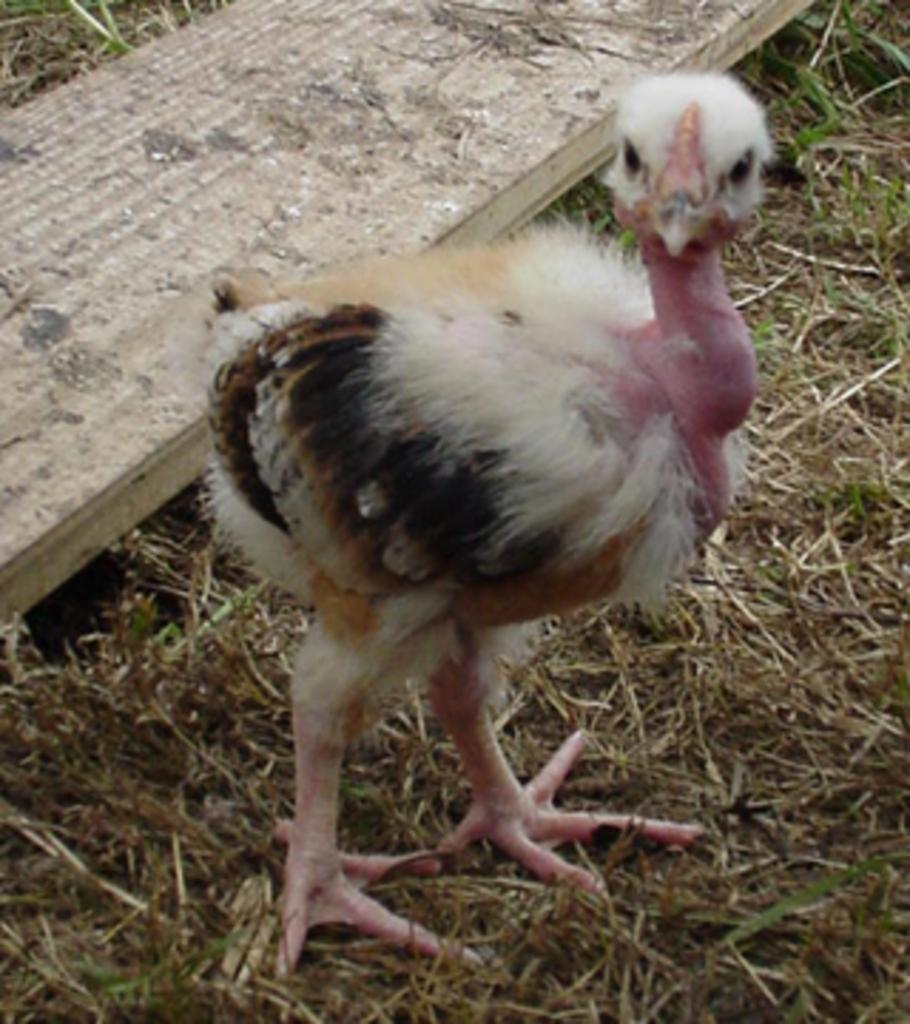What type of animal can be seen in the image? There is a bird in the image. What material is the sheet in the image made of? There is a wooden sheet in the image. What type of vegetation is visible in the image? There is grass in the image. What type of pencil can be seen in the image? There is no pencil present in the image. Are there any rail tracks visible in the image? There are no rail tracks present in the image. 